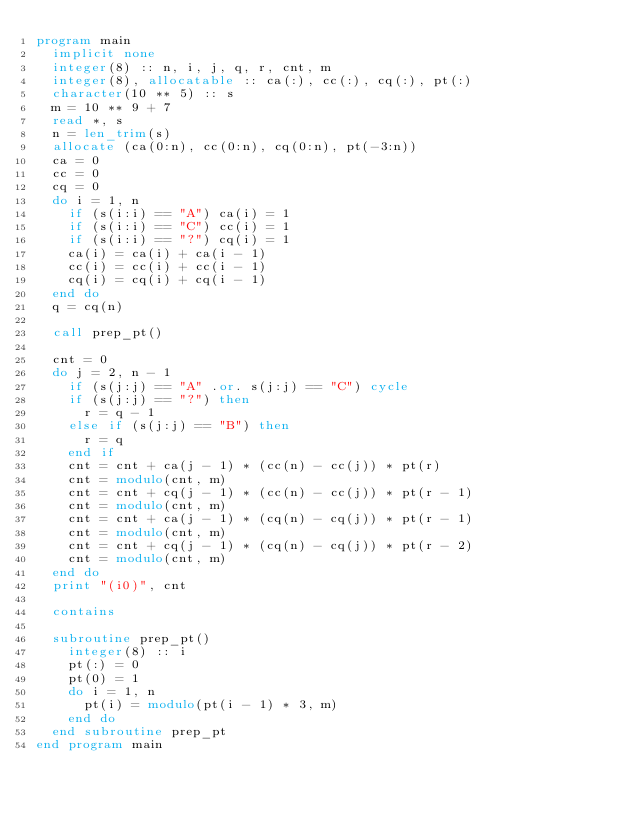Convert code to text. <code><loc_0><loc_0><loc_500><loc_500><_FORTRAN_>program main
  implicit none
  integer(8) :: n, i, j, q, r, cnt, m
  integer(8), allocatable :: ca(:), cc(:), cq(:), pt(:)
  character(10 ** 5) :: s
  m = 10 ** 9 + 7
  read *, s
  n = len_trim(s)
  allocate (ca(0:n), cc(0:n), cq(0:n), pt(-3:n))
  ca = 0
  cc = 0
  cq = 0
  do i = 1, n
    if (s(i:i) == "A") ca(i) = 1
    if (s(i:i) == "C") cc(i) = 1
    if (s(i:i) == "?") cq(i) = 1
    ca(i) = ca(i) + ca(i - 1)
    cc(i) = cc(i) + cc(i - 1)
    cq(i) = cq(i) + cq(i - 1)
  end do
  q = cq(n)

  call prep_pt()

  cnt = 0
  do j = 2, n - 1
    if (s(j:j) == "A" .or. s(j:j) == "C") cycle
    if (s(j:j) == "?") then
      r = q - 1
    else if (s(j:j) == "B") then
      r = q
    end if
    cnt = cnt + ca(j - 1) * (cc(n) - cc(j)) * pt(r)
    cnt = modulo(cnt, m)
    cnt = cnt + cq(j - 1) * (cc(n) - cc(j)) * pt(r - 1)
    cnt = modulo(cnt, m)
    cnt = cnt + ca(j - 1) * (cq(n) - cq(j)) * pt(r - 1)
    cnt = modulo(cnt, m)
    cnt = cnt + cq(j - 1) * (cq(n) - cq(j)) * pt(r - 2)
    cnt = modulo(cnt, m)
  end do
  print "(i0)", cnt

  contains

  subroutine prep_pt()
    integer(8) :: i
    pt(:) = 0
    pt(0) = 1
    do i = 1, n
      pt(i) = modulo(pt(i - 1) * 3, m)
    end do
  end subroutine prep_pt
end program main
</code> 